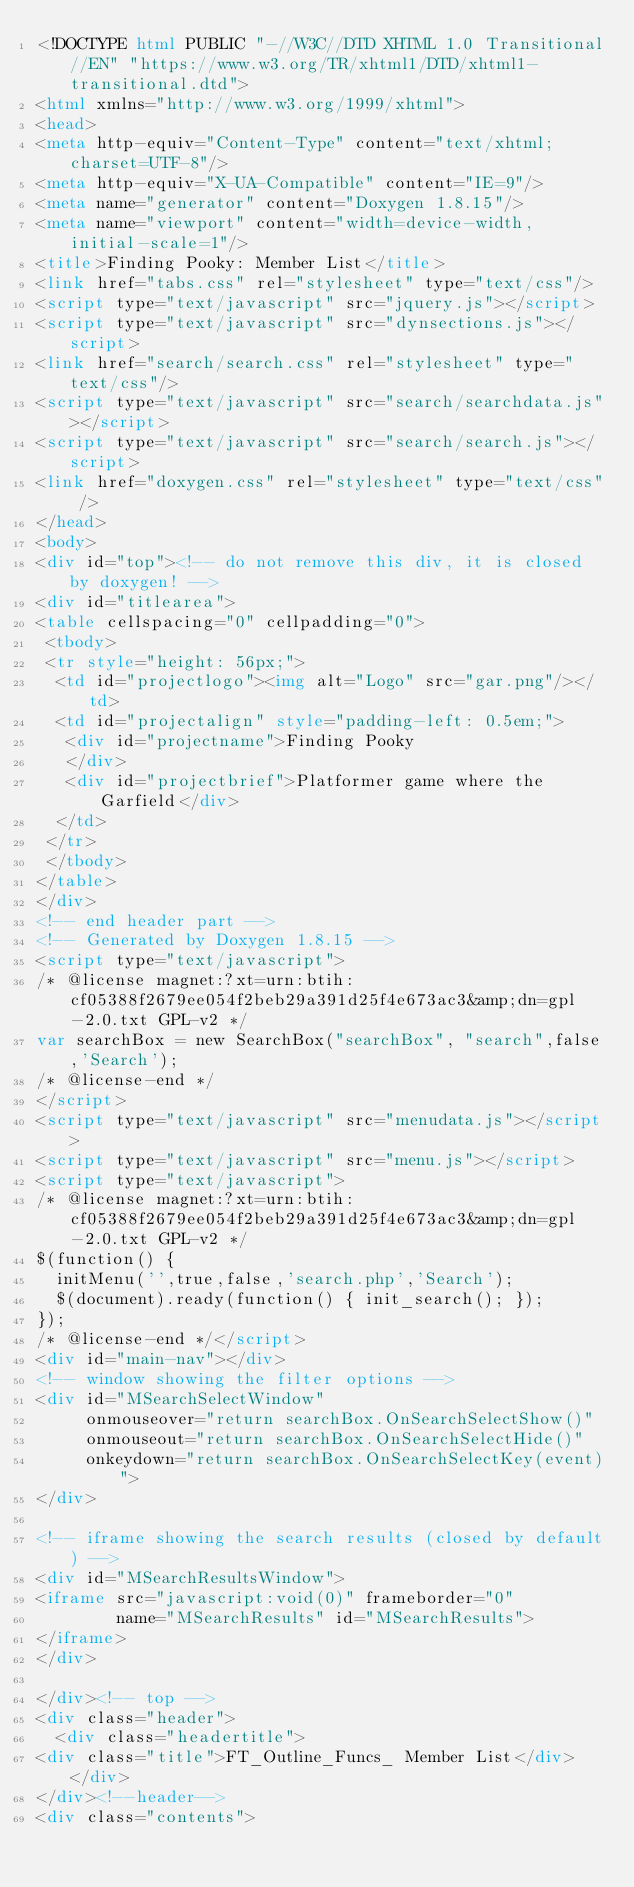<code> <loc_0><loc_0><loc_500><loc_500><_HTML_><!DOCTYPE html PUBLIC "-//W3C//DTD XHTML 1.0 Transitional//EN" "https://www.w3.org/TR/xhtml1/DTD/xhtml1-transitional.dtd">
<html xmlns="http://www.w3.org/1999/xhtml">
<head>
<meta http-equiv="Content-Type" content="text/xhtml;charset=UTF-8"/>
<meta http-equiv="X-UA-Compatible" content="IE=9"/>
<meta name="generator" content="Doxygen 1.8.15"/>
<meta name="viewport" content="width=device-width, initial-scale=1"/>
<title>Finding Pooky: Member List</title>
<link href="tabs.css" rel="stylesheet" type="text/css"/>
<script type="text/javascript" src="jquery.js"></script>
<script type="text/javascript" src="dynsections.js"></script>
<link href="search/search.css" rel="stylesheet" type="text/css"/>
<script type="text/javascript" src="search/searchdata.js"></script>
<script type="text/javascript" src="search/search.js"></script>
<link href="doxygen.css" rel="stylesheet" type="text/css" />
</head>
<body>
<div id="top"><!-- do not remove this div, it is closed by doxygen! -->
<div id="titlearea">
<table cellspacing="0" cellpadding="0">
 <tbody>
 <tr style="height: 56px;">
  <td id="projectlogo"><img alt="Logo" src="gar.png"/></td>
  <td id="projectalign" style="padding-left: 0.5em;">
   <div id="projectname">Finding Pooky
   </div>
   <div id="projectbrief">Platformer game where the Garfield</div>
  </td>
 </tr>
 </tbody>
</table>
</div>
<!-- end header part -->
<!-- Generated by Doxygen 1.8.15 -->
<script type="text/javascript">
/* @license magnet:?xt=urn:btih:cf05388f2679ee054f2beb29a391d25f4e673ac3&amp;dn=gpl-2.0.txt GPL-v2 */
var searchBox = new SearchBox("searchBox", "search",false,'Search');
/* @license-end */
</script>
<script type="text/javascript" src="menudata.js"></script>
<script type="text/javascript" src="menu.js"></script>
<script type="text/javascript">
/* @license magnet:?xt=urn:btih:cf05388f2679ee054f2beb29a391d25f4e673ac3&amp;dn=gpl-2.0.txt GPL-v2 */
$(function() {
  initMenu('',true,false,'search.php','Search');
  $(document).ready(function() { init_search(); });
});
/* @license-end */</script>
<div id="main-nav"></div>
<!-- window showing the filter options -->
<div id="MSearchSelectWindow"
     onmouseover="return searchBox.OnSearchSelectShow()"
     onmouseout="return searchBox.OnSearchSelectHide()"
     onkeydown="return searchBox.OnSearchSelectKey(event)">
</div>

<!-- iframe showing the search results (closed by default) -->
<div id="MSearchResultsWindow">
<iframe src="javascript:void(0)" frameborder="0" 
        name="MSearchResults" id="MSearchResults">
</iframe>
</div>

</div><!-- top -->
<div class="header">
  <div class="headertitle">
<div class="title">FT_Outline_Funcs_ Member List</div>  </div>
</div><!--header-->
<div class="contents">
</code> 